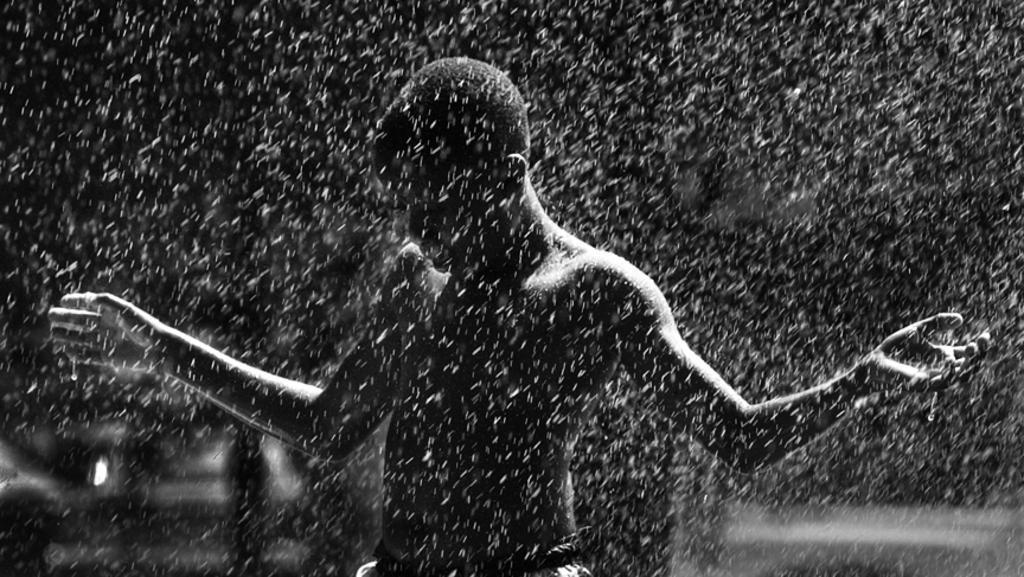Please provide a concise description of this image. This is a black and white picture. In this picture, we see a man is standing. It might be raining. In the background, it is black in color. This might be an edited image. 